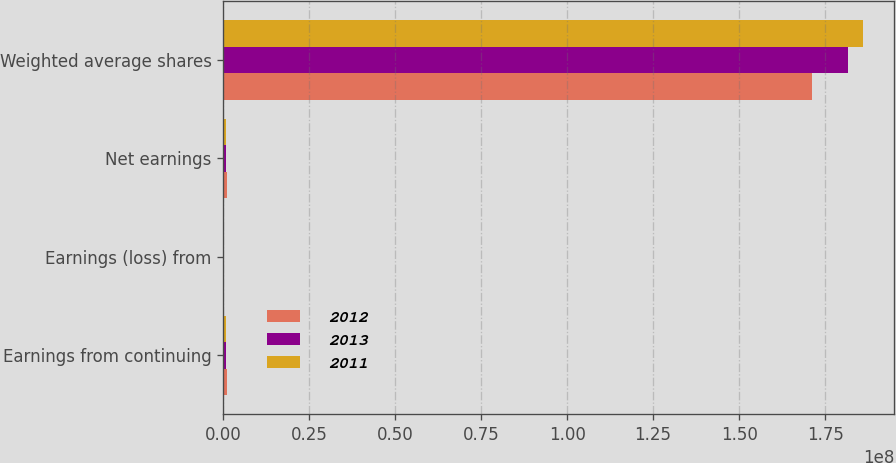Convert chart to OTSL. <chart><loc_0><loc_0><loc_500><loc_500><stacked_bar_chart><ecel><fcel>Earnings from continuing<fcel>Earnings (loss) from<fcel>Net earnings<fcel>Weighted average shares<nl><fcel>2012<fcel>965805<fcel>37324<fcel>1.00313e+06<fcel>1.71271e+08<nl><fcel>2013<fcel>833119<fcel>22049<fcel>811070<fcel>1.81551e+08<nl><fcel>2011<fcel>773186<fcel>122057<fcel>895243<fcel>1.85882e+08<nl></chart> 